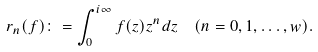Convert formula to latex. <formula><loc_0><loc_0><loc_500><loc_500>r _ { n } ( f ) \colon = \int _ { 0 } ^ { i \infty } f ( z ) z ^ { n } d z \ \ ( n = 0 , 1 , \dots , w ) .</formula> 